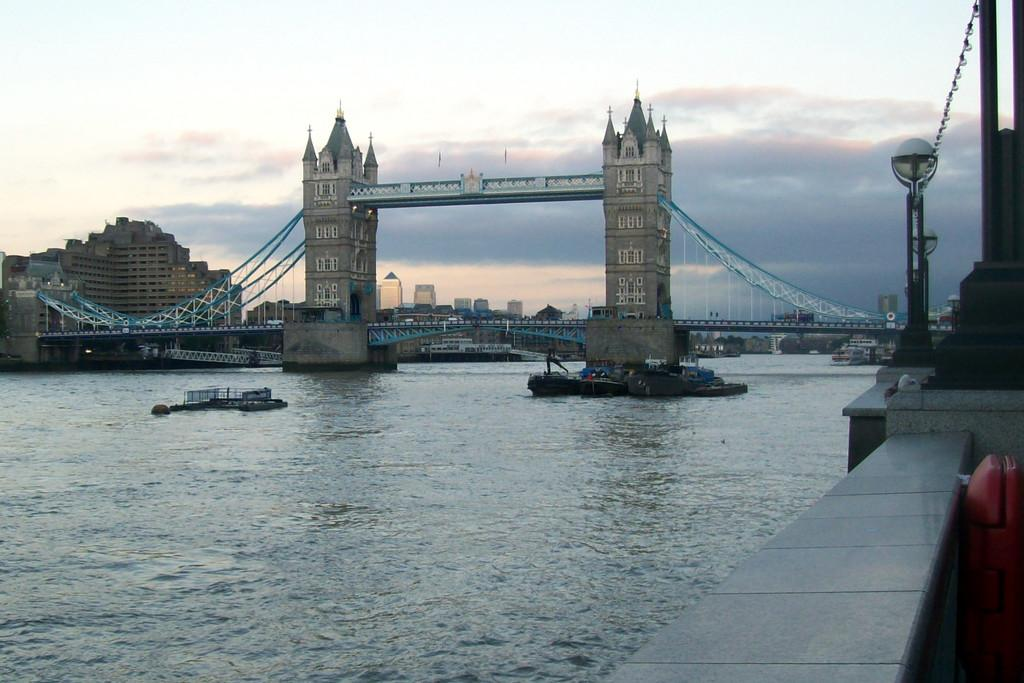What type of structures can be seen in the image? There are buildings in the image. What feature do the buildings have? The buildings have windows. What natural element is visible in the image? There is water visible in the image. What is floating on the water? There is a boat in the water. What type of vertical structure is present in the image? There is a light pole in the image. What type of man-made structure connects two points in the image? There is a bridge in the image. How would you describe the sky in the image? The sky is cloudy in the image. What type of marble is present in the image? There is no marble present in the image. 